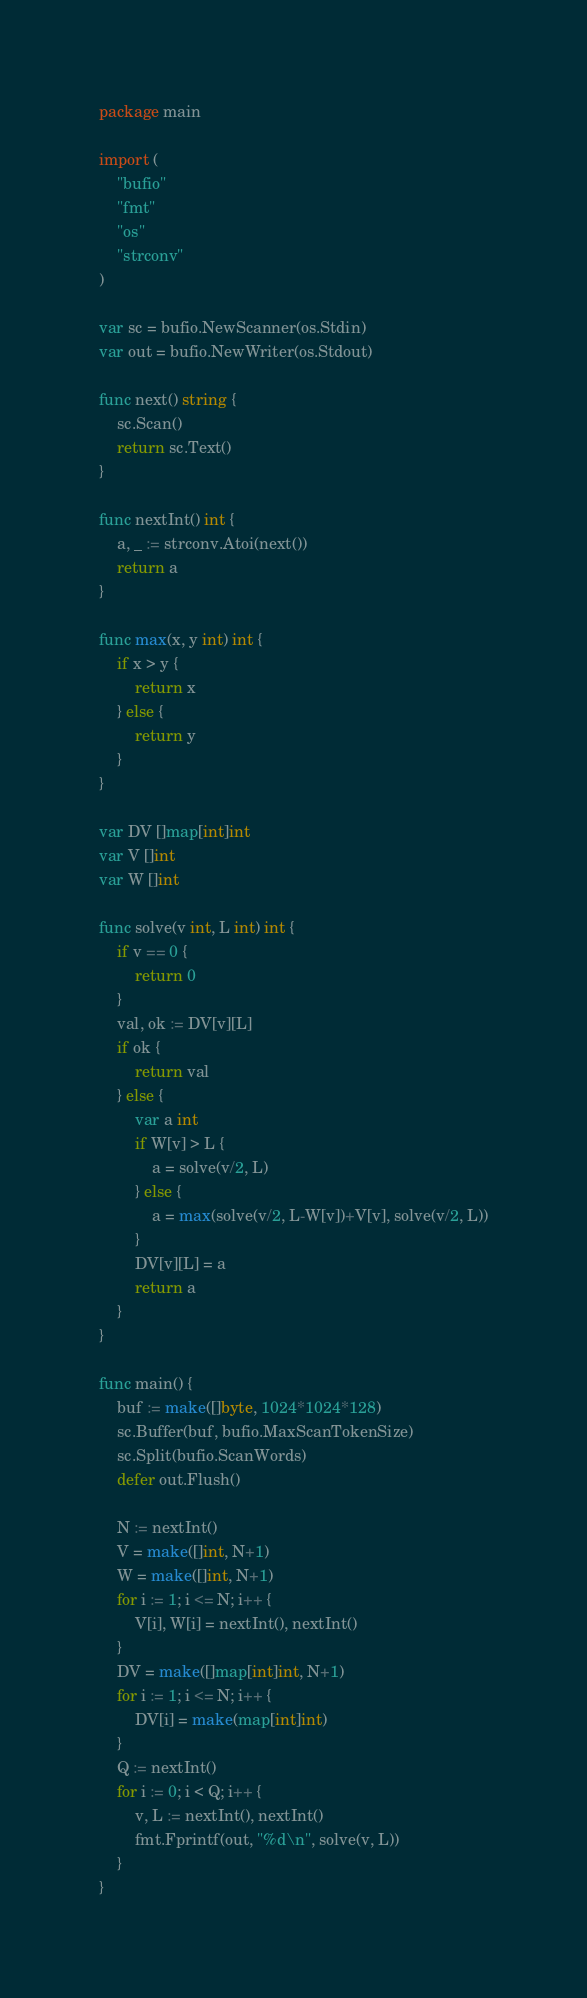<code> <loc_0><loc_0><loc_500><loc_500><_Go_>package main

import (
	"bufio"
	"fmt"
	"os"
	"strconv"
)

var sc = bufio.NewScanner(os.Stdin)
var out = bufio.NewWriter(os.Stdout)

func next() string {
	sc.Scan()
	return sc.Text()
}

func nextInt() int {
	a, _ := strconv.Atoi(next())
	return a
}

func max(x, y int) int {
	if x > y {
		return x
	} else {
		return y
	}
}

var DV []map[int]int
var V []int
var W []int

func solve(v int, L int) int {
	if v == 0 {
		return 0
	}
	val, ok := DV[v][L]
	if ok {
		return val
	} else {
		var a int
		if W[v] > L {
			a = solve(v/2, L)
		} else {
			a = max(solve(v/2, L-W[v])+V[v], solve(v/2, L))
		}
		DV[v][L] = a
		return a
	}
}

func main() {
	buf := make([]byte, 1024*1024*128)
	sc.Buffer(buf, bufio.MaxScanTokenSize)
	sc.Split(bufio.ScanWords)
	defer out.Flush()

	N := nextInt()
	V = make([]int, N+1)
	W = make([]int, N+1)
	for i := 1; i <= N; i++ {
		V[i], W[i] = nextInt(), nextInt()
	}
	DV = make([]map[int]int, N+1)
	for i := 1; i <= N; i++ {
		DV[i] = make(map[int]int)
	}
	Q := nextInt()
	for i := 0; i < Q; i++ {
		v, L := nextInt(), nextInt()
		fmt.Fprintf(out, "%d\n", solve(v, L))
	}
}
</code> 